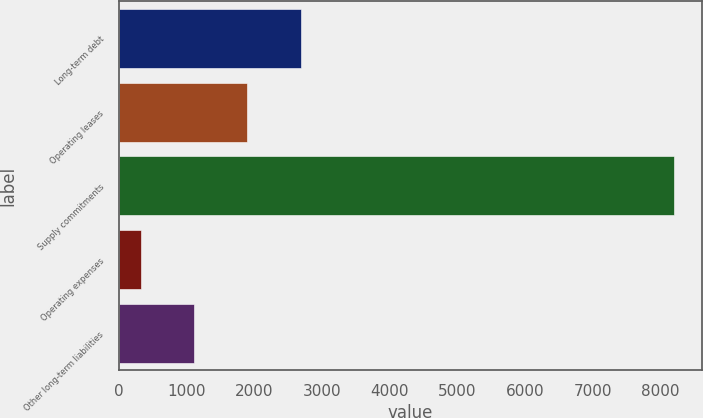<chart> <loc_0><loc_0><loc_500><loc_500><bar_chart><fcel>Long-term debt<fcel>Operating leases<fcel>Supply commitments<fcel>Operating expenses<fcel>Other long-term liabilities<nl><fcel>2685.9<fcel>1897.6<fcel>8204<fcel>321<fcel>1109.3<nl></chart> 